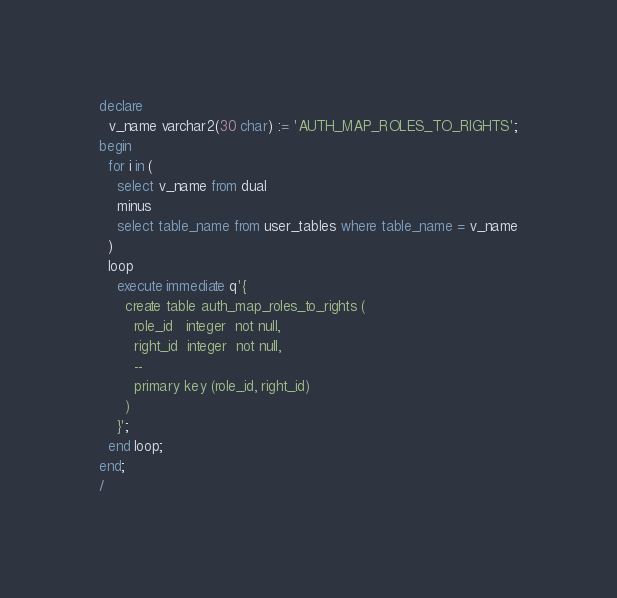<code> <loc_0><loc_0><loc_500><loc_500><_SQL_>declare
  v_name varchar2(30 char) := 'AUTH_MAP_ROLES_TO_RIGHTS';
begin
  for i in (
    select v_name from dual
    minus
    select table_name from user_tables where table_name = v_name
  )
  loop
    execute immediate q'{
      create table auth_map_roles_to_rights (
        role_id   integer  not null,
        right_id  integer  not null,
        --
        primary key (role_id, right_id)
      )
    }';
  end loop;
end;
/
</code> 